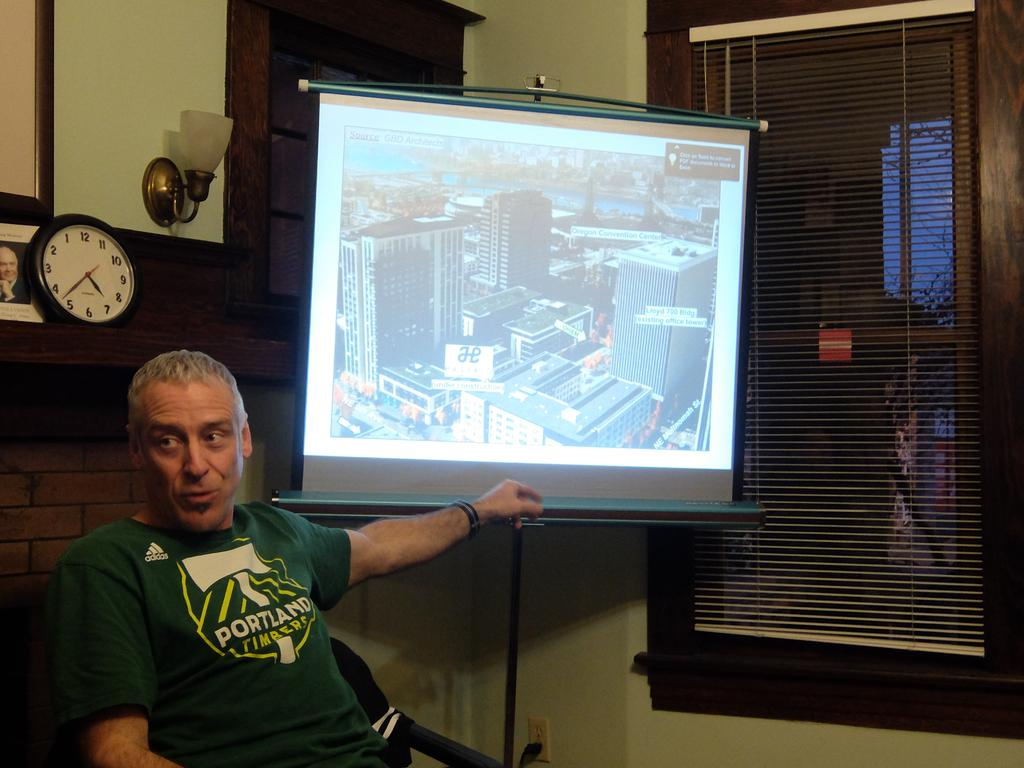<image>
Give a short and clear explanation of the subsequent image. A man wearing a green Portland Timbers shirt is sitting next to a projection screen, in front of a fireplace. 